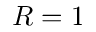<formula> <loc_0><loc_0><loc_500><loc_500>R = 1</formula> 